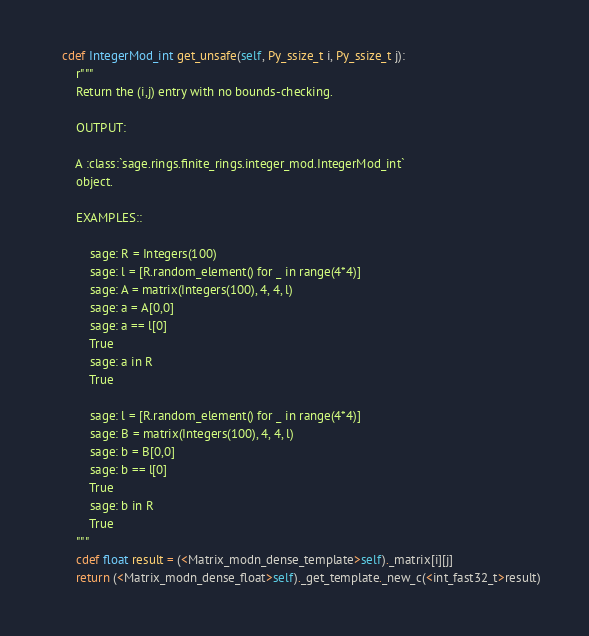<code> <loc_0><loc_0><loc_500><loc_500><_Cython_>    cdef IntegerMod_int get_unsafe(self, Py_ssize_t i, Py_ssize_t j):
        r"""
        Return the (i,j) entry with no bounds-checking.

        OUTPUT:

        A :class:`sage.rings.finite_rings.integer_mod.IntegerMod_int`
        object.

        EXAMPLES::

            sage: R = Integers(100)
            sage: l = [R.random_element() for _ in range(4*4)]
            sage: A = matrix(Integers(100), 4, 4, l)
            sage: a = A[0,0]
            sage: a == l[0]
            True
            sage: a in R
            True

            sage: l = [R.random_element() for _ in range(4*4)]
            sage: B = matrix(Integers(100), 4, 4, l)
            sage: b = B[0,0]
            sage: b == l[0]
            True
            sage: b in R
            True
        """
        cdef float result = (<Matrix_modn_dense_template>self)._matrix[i][j]
        return (<Matrix_modn_dense_float>self)._get_template._new_c(<int_fast32_t>result)
</code> 